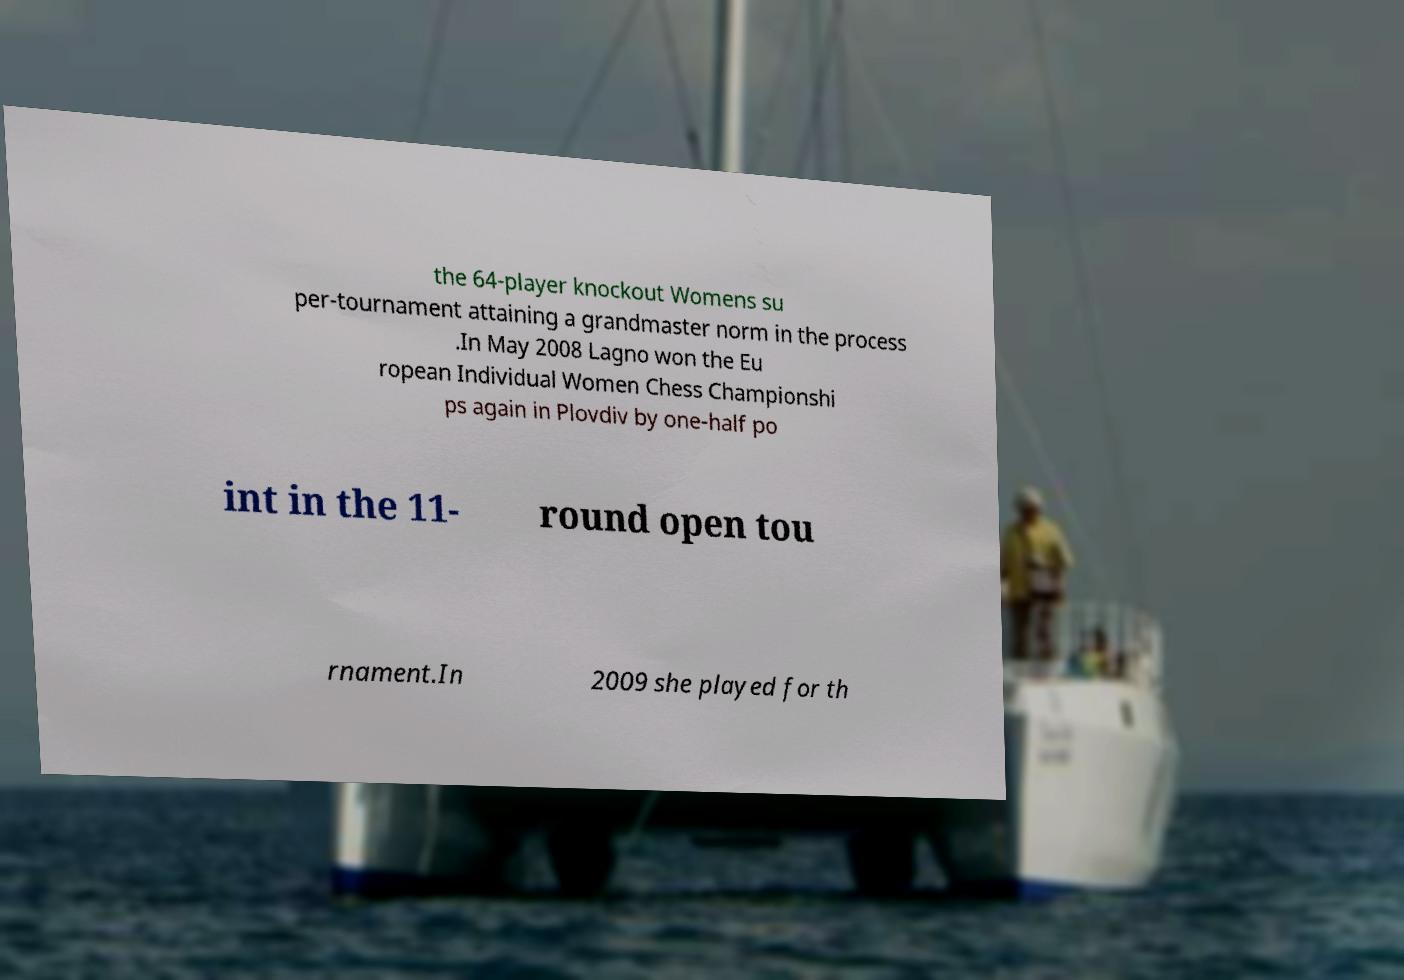Could you extract and type out the text from this image? the 64-player knockout Womens su per-tournament attaining a grandmaster norm in the process .In May 2008 Lagno won the Eu ropean Individual Women Chess Championshi ps again in Plovdiv by one-half po int in the 11- round open tou rnament.In 2009 she played for th 